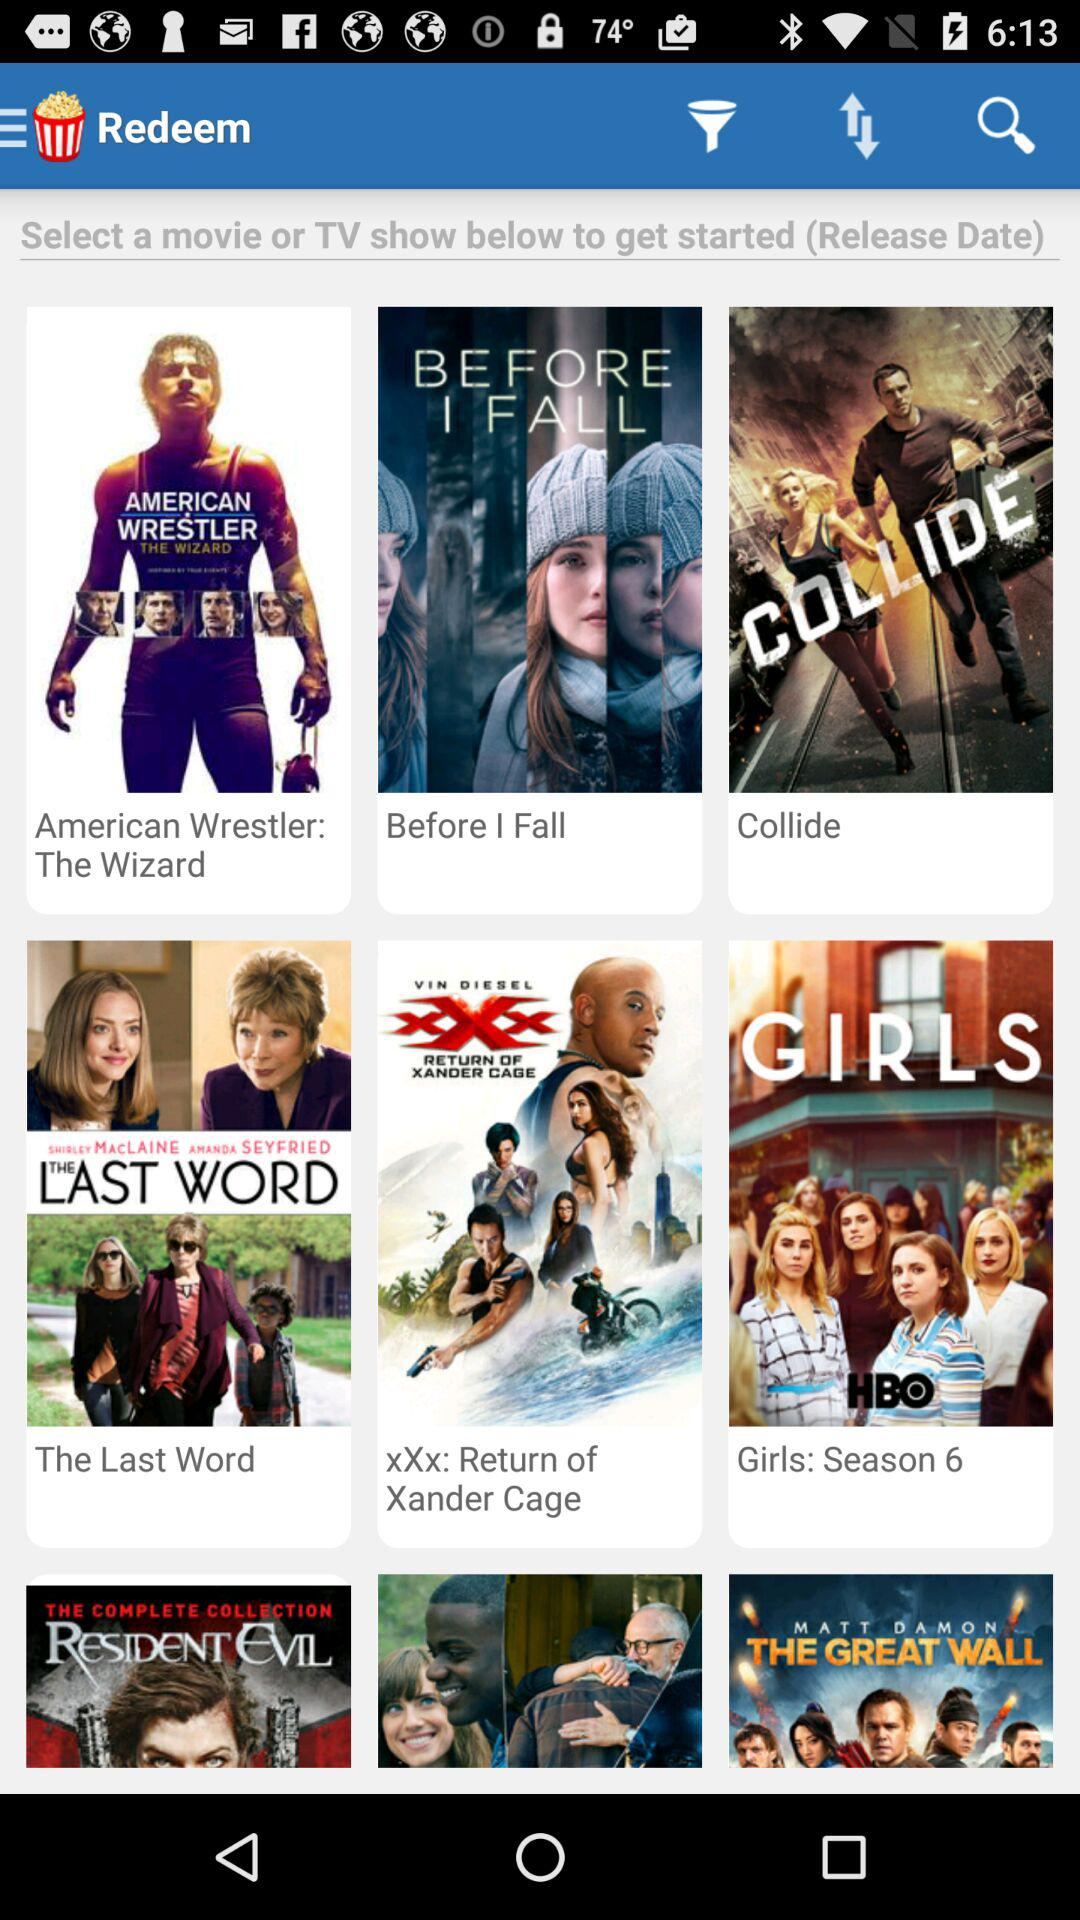What is the name of the movie and TV show? The names of the movies and TV shows are "American Wrestler: The Wizard", "Before I Fall", "Collide", "The Last Word", "xXx: Return of Xander Cage" and "Girls: Season 6". 